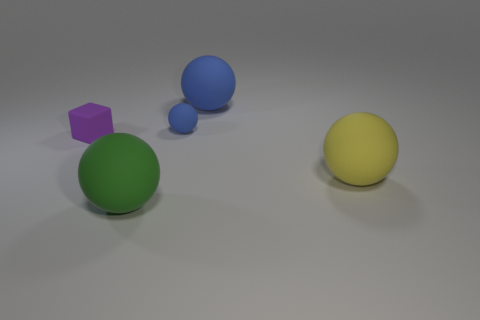What is the material of the large blue object that is the same shape as the big green thing?
Your answer should be compact. Rubber. There is a big ball that is behind the big yellow object; is there a large rubber ball that is behind it?
Keep it short and to the point. No. Do the yellow thing and the large green object have the same shape?
Your response must be concise. Yes. There is a yellow object that is the same material as the green ball; what shape is it?
Provide a short and direct response. Sphere. Does the matte sphere that is in front of the yellow matte sphere have the same size as the yellow matte object right of the small sphere?
Offer a very short reply. Yes. Are there more purple cubes to the left of the big blue sphere than matte blocks in front of the big yellow rubber ball?
Offer a terse response. Yes. What number of other things are the same color as the rubber cube?
Provide a short and direct response. 0. Is the color of the tiny ball the same as the big rubber object behind the yellow rubber object?
Offer a very short reply. Yes. There is a small block left of the yellow ball; how many large green balls are behind it?
Ensure brevity in your answer.  0. There is a thing that is both on the right side of the green object and in front of the small purple matte cube; what material is it?
Keep it short and to the point. Rubber. 